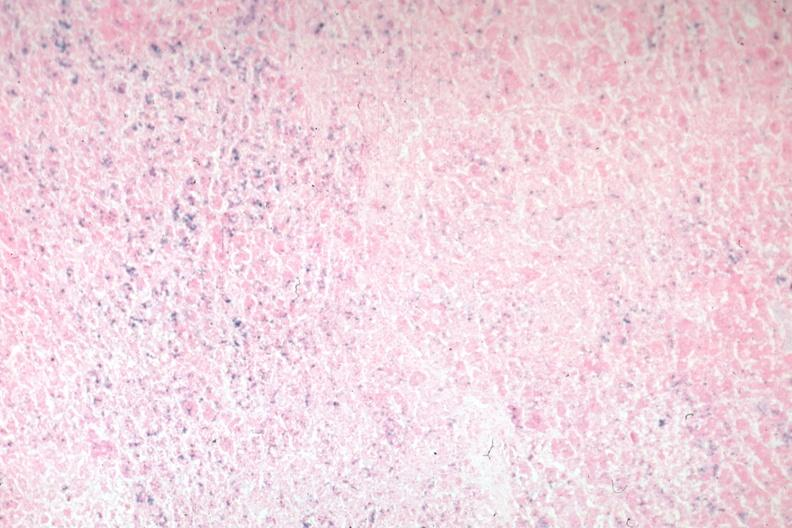what does this image show?
Answer the question using a single word or phrase. Iron stain 